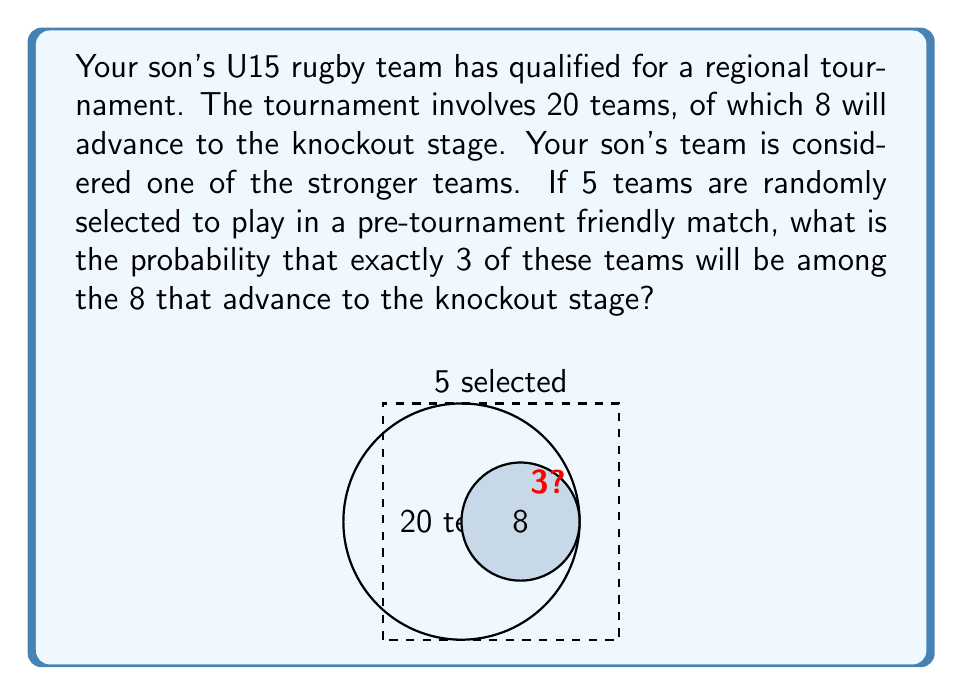Provide a solution to this math problem. To solve this problem, we need to use the hypergeometric distribution. This distribution is appropriate when we're sampling without replacement from a finite population.

Let's define our parameters:
- $N = 20$ (total number of teams)
- $K = 8$ (number of teams that advance)
- $n = 5$ (number of teams selected for the friendly match)
- $k = 3$ (number of advancing teams we want in our selection)

The probability mass function for the hypergeometric distribution is:

$$ P(X = k) = \frac{\binom{K}{k} \binom{N-K}{n-k}}{\binom{N}{n}} $$

Let's calculate each part:

1) $\binom{K}{k} = \binom{8}{3} = 56$
   This is the number of ways to choose 3 advancing teams from the 8 that will advance.

2) $\binom{N-K}{n-k} = \binom{12}{2} = 66$
   This is the number of ways to choose the remaining 2 teams from the 12 that won't advance.

3) $\binom{N}{n} = \binom{20}{5} = 15504$
   This is the total number of ways to choose 5 teams from 20.

Now, let's plug these values into our equation:

$$ P(X = 3) = \frac{56 \cdot 66}{15504} = \frac{3696}{15504} = \frac{231}{969} \approx 0.2384 $$

Therefore, the probability is approximately 0.2384 or about 23.84%.
Answer: $\frac{231}{969}$ or approximately 0.2384 